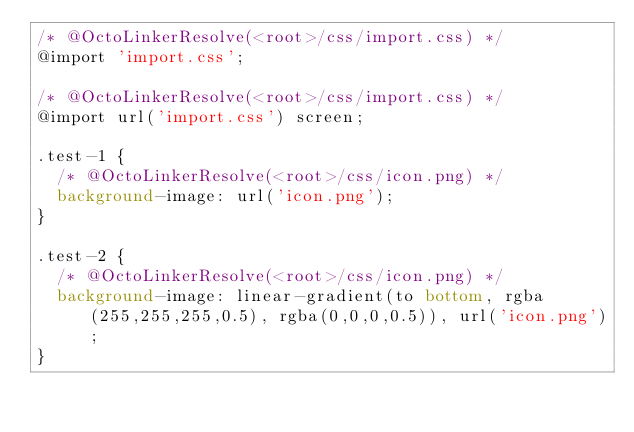<code> <loc_0><loc_0><loc_500><loc_500><_CSS_>/* @OctoLinkerResolve(<root>/css/import.css) */
@import 'import.css';

/* @OctoLinkerResolve(<root>/css/import.css) */
@import url('import.css') screen;

.test-1 {
  /* @OctoLinkerResolve(<root>/css/icon.png) */
  background-image: url('icon.png');
}

.test-2 {
  /* @OctoLinkerResolve(<root>/css/icon.png) */
  background-image: linear-gradient(to bottom, rgba(255,255,255,0.5), rgba(0,0,0,0.5)), url('icon.png');
}
</code> 